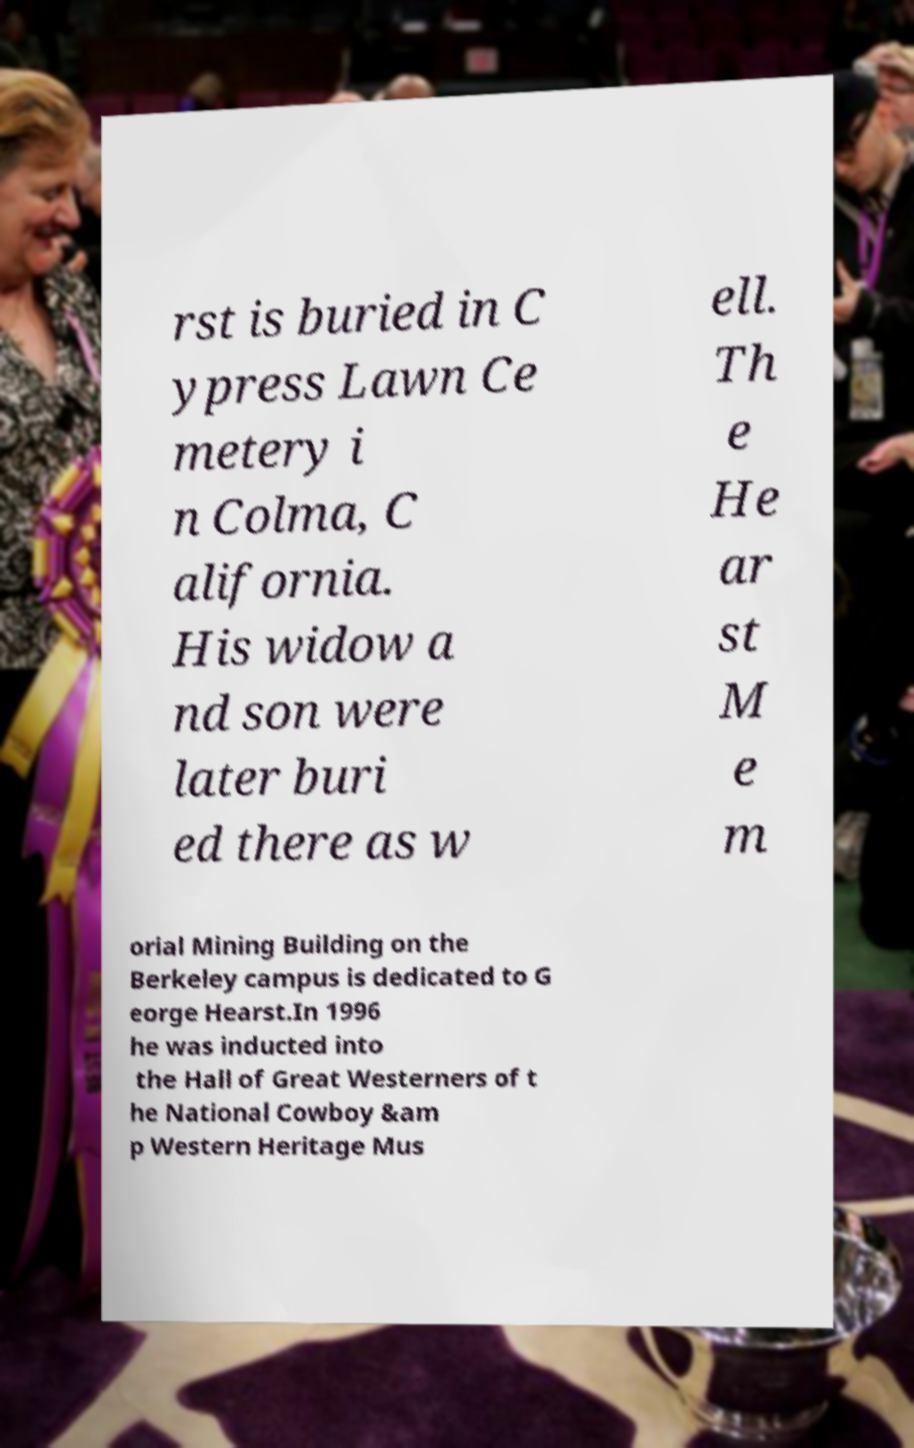Can you read and provide the text displayed in the image?This photo seems to have some interesting text. Can you extract and type it out for me? rst is buried in C ypress Lawn Ce metery i n Colma, C alifornia. His widow a nd son were later buri ed there as w ell. Th e He ar st M e m orial Mining Building on the Berkeley campus is dedicated to G eorge Hearst.In 1996 he was inducted into the Hall of Great Westerners of t he National Cowboy &am p Western Heritage Mus 